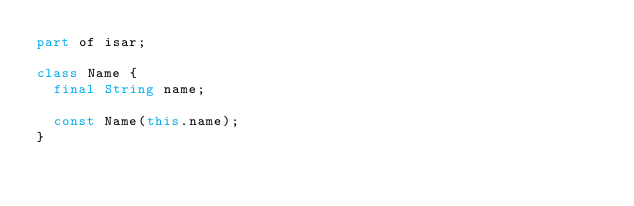Convert code to text. <code><loc_0><loc_0><loc_500><loc_500><_Dart_>part of isar;

class Name {
  final String name;

  const Name(this.name);
}
</code> 